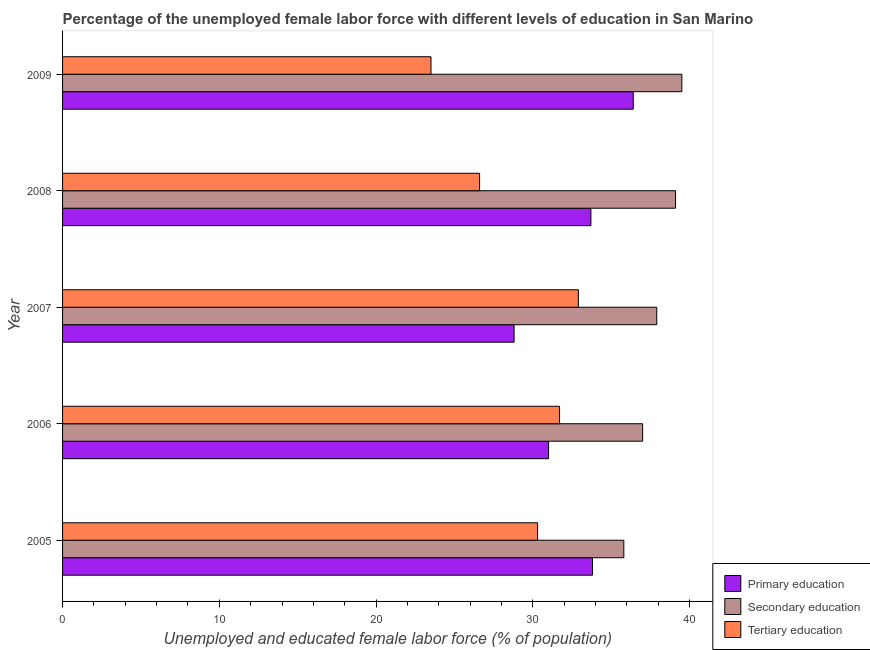How many different coloured bars are there?
Ensure brevity in your answer.  3. How many groups of bars are there?
Offer a very short reply. 5. Are the number of bars on each tick of the Y-axis equal?
Your response must be concise. Yes. How many bars are there on the 5th tick from the top?
Your response must be concise. 3. How many bars are there on the 2nd tick from the bottom?
Keep it short and to the point. 3. What is the label of the 5th group of bars from the top?
Your answer should be very brief. 2005. In how many cases, is the number of bars for a given year not equal to the number of legend labels?
Your answer should be very brief. 0. What is the percentage of female labor force who received secondary education in 2008?
Offer a very short reply. 39.1. Across all years, what is the maximum percentage of female labor force who received primary education?
Your answer should be very brief. 36.4. Across all years, what is the minimum percentage of female labor force who received primary education?
Make the answer very short. 28.8. In which year was the percentage of female labor force who received primary education minimum?
Your answer should be compact. 2007. What is the total percentage of female labor force who received secondary education in the graph?
Your response must be concise. 189.3. What is the difference between the percentage of female labor force who received tertiary education in 2008 and the percentage of female labor force who received secondary education in 2005?
Your response must be concise. -9.2. What is the ratio of the percentage of female labor force who received primary education in 2006 to that in 2009?
Make the answer very short. 0.85. What is the difference between the highest and the lowest percentage of female labor force who received tertiary education?
Your answer should be compact. 9.4. Is the sum of the percentage of female labor force who received primary education in 2006 and 2009 greater than the maximum percentage of female labor force who received tertiary education across all years?
Give a very brief answer. Yes. What does the 2nd bar from the top in 2007 represents?
Give a very brief answer. Secondary education. What does the 2nd bar from the bottom in 2005 represents?
Your answer should be very brief. Secondary education. Is it the case that in every year, the sum of the percentage of female labor force who received primary education and percentage of female labor force who received secondary education is greater than the percentage of female labor force who received tertiary education?
Your answer should be compact. Yes. How many bars are there?
Make the answer very short. 15. Does the graph contain grids?
Your response must be concise. No. Where does the legend appear in the graph?
Provide a succinct answer. Bottom right. What is the title of the graph?
Keep it short and to the point. Percentage of the unemployed female labor force with different levels of education in San Marino. Does "Travel services" appear as one of the legend labels in the graph?
Offer a terse response. No. What is the label or title of the X-axis?
Offer a very short reply. Unemployed and educated female labor force (% of population). What is the Unemployed and educated female labor force (% of population) of Primary education in 2005?
Offer a very short reply. 33.8. What is the Unemployed and educated female labor force (% of population) of Secondary education in 2005?
Ensure brevity in your answer.  35.8. What is the Unemployed and educated female labor force (% of population) of Tertiary education in 2005?
Your response must be concise. 30.3. What is the Unemployed and educated female labor force (% of population) of Primary education in 2006?
Ensure brevity in your answer.  31. What is the Unemployed and educated female labor force (% of population) in Tertiary education in 2006?
Offer a terse response. 31.7. What is the Unemployed and educated female labor force (% of population) in Primary education in 2007?
Your answer should be very brief. 28.8. What is the Unemployed and educated female labor force (% of population) of Secondary education in 2007?
Give a very brief answer. 37.9. What is the Unemployed and educated female labor force (% of population) of Tertiary education in 2007?
Your response must be concise. 32.9. What is the Unemployed and educated female labor force (% of population) of Primary education in 2008?
Make the answer very short. 33.7. What is the Unemployed and educated female labor force (% of population) of Secondary education in 2008?
Your answer should be very brief. 39.1. What is the Unemployed and educated female labor force (% of population) in Tertiary education in 2008?
Make the answer very short. 26.6. What is the Unemployed and educated female labor force (% of population) of Primary education in 2009?
Make the answer very short. 36.4. What is the Unemployed and educated female labor force (% of population) of Secondary education in 2009?
Offer a very short reply. 39.5. What is the Unemployed and educated female labor force (% of population) in Tertiary education in 2009?
Offer a terse response. 23.5. Across all years, what is the maximum Unemployed and educated female labor force (% of population) in Primary education?
Provide a succinct answer. 36.4. Across all years, what is the maximum Unemployed and educated female labor force (% of population) of Secondary education?
Give a very brief answer. 39.5. Across all years, what is the maximum Unemployed and educated female labor force (% of population) in Tertiary education?
Give a very brief answer. 32.9. Across all years, what is the minimum Unemployed and educated female labor force (% of population) in Primary education?
Your answer should be compact. 28.8. Across all years, what is the minimum Unemployed and educated female labor force (% of population) of Secondary education?
Offer a terse response. 35.8. Across all years, what is the minimum Unemployed and educated female labor force (% of population) of Tertiary education?
Keep it short and to the point. 23.5. What is the total Unemployed and educated female labor force (% of population) in Primary education in the graph?
Your answer should be very brief. 163.7. What is the total Unemployed and educated female labor force (% of population) in Secondary education in the graph?
Keep it short and to the point. 189.3. What is the total Unemployed and educated female labor force (% of population) of Tertiary education in the graph?
Give a very brief answer. 145. What is the difference between the Unemployed and educated female labor force (% of population) in Secondary education in 2005 and that in 2006?
Give a very brief answer. -1.2. What is the difference between the Unemployed and educated female labor force (% of population) in Tertiary education in 2005 and that in 2006?
Provide a succinct answer. -1.4. What is the difference between the Unemployed and educated female labor force (% of population) in Primary education in 2005 and that in 2008?
Your answer should be compact. 0.1. What is the difference between the Unemployed and educated female labor force (% of population) in Primary education in 2005 and that in 2009?
Give a very brief answer. -2.6. What is the difference between the Unemployed and educated female labor force (% of population) of Tertiary education in 2005 and that in 2009?
Offer a terse response. 6.8. What is the difference between the Unemployed and educated female labor force (% of population) of Tertiary education in 2006 and that in 2008?
Ensure brevity in your answer.  5.1. What is the difference between the Unemployed and educated female labor force (% of population) of Primary education in 2006 and that in 2009?
Provide a short and direct response. -5.4. What is the difference between the Unemployed and educated female labor force (% of population) in Secondary education in 2006 and that in 2009?
Keep it short and to the point. -2.5. What is the difference between the Unemployed and educated female labor force (% of population) of Primary education in 2007 and that in 2008?
Make the answer very short. -4.9. What is the difference between the Unemployed and educated female labor force (% of population) of Tertiary education in 2007 and that in 2008?
Give a very brief answer. 6.3. What is the difference between the Unemployed and educated female labor force (% of population) in Primary education in 2007 and that in 2009?
Make the answer very short. -7.6. What is the difference between the Unemployed and educated female labor force (% of population) of Secondary education in 2007 and that in 2009?
Ensure brevity in your answer.  -1.6. What is the difference between the Unemployed and educated female labor force (% of population) of Primary education in 2008 and that in 2009?
Offer a very short reply. -2.7. What is the difference between the Unemployed and educated female labor force (% of population) in Secondary education in 2008 and that in 2009?
Offer a very short reply. -0.4. What is the difference between the Unemployed and educated female labor force (% of population) of Primary education in 2005 and the Unemployed and educated female labor force (% of population) of Secondary education in 2006?
Offer a very short reply. -3.2. What is the difference between the Unemployed and educated female labor force (% of population) in Primary education in 2005 and the Unemployed and educated female labor force (% of population) in Tertiary education in 2008?
Give a very brief answer. 7.2. What is the difference between the Unemployed and educated female labor force (% of population) of Secondary education in 2005 and the Unemployed and educated female labor force (% of population) of Tertiary education in 2008?
Your response must be concise. 9.2. What is the difference between the Unemployed and educated female labor force (% of population) in Primary education in 2005 and the Unemployed and educated female labor force (% of population) in Secondary education in 2009?
Ensure brevity in your answer.  -5.7. What is the difference between the Unemployed and educated female labor force (% of population) of Primary education in 2005 and the Unemployed and educated female labor force (% of population) of Tertiary education in 2009?
Provide a short and direct response. 10.3. What is the difference between the Unemployed and educated female labor force (% of population) of Secondary education in 2005 and the Unemployed and educated female labor force (% of population) of Tertiary education in 2009?
Provide a short and direct response. 12.3. What is the difference between the Unemployed and educated female labor force (% of population) of Primary education in 2006 and the Unemployed and educated female labor force (% of population) of Secondary education in 2007?
Provide a short and direct response. -6.9. What is the difference between the Unemployed and educated female labor force (% of population) of Primary education in 2006 and the Unemployed and educated female labor force (% of population) of Tertiary education in 2007?
Provide a succinct answer. -1.9. What is the difference between the Unemployed and educated female labor force (% of population) in Secondary education in 2006 and the Unemployed and educated female labor force (% of population) in Tertiary education in 2008?
Your response must be concise. 10.4. What is the difference between the Unemployed and educated female labor force (% of population) of Primary education in 2006 and the Unemployed and educated female labor force (% of population) of Secondary education in 2009?
Keep it short and to the point. -8.5. What is the difference between the Unemployed and educated female labor force (% of population) in Primary education in 2006 and the Unemployed and educated female labor force (% of population) in Tertiary education in 2009?
Your response must be concise. 7.5. What is the difference between the Unemployed and educated female labor force (% of population) of Secondary education in 2006 and the Unemployed and educated female labor force (% of population) of Tertiary education in 2009?
Offer a very short reply. 13.5. What is the difference between the Unemployed and educated female labor force (% of population) of Primary education in 2007 and the Unemployed and educated female labor force (% of population) of Secondary education in 2008?
Make the answer very short. -10.3. What is the difference between the Unemployed and educated female labor force (% of population) of Secondary education in 2007 and the Unemployed and educated female labor force (% of population) of Tertiary education in 2008?
Give a very brief answer. 11.3. What is the difference between the Unemployed and educated female labor force (% of population) of Primary education in 2007 and the Unemployed and educated female labor force (% of population) of Secondary education in 2009?
Offer a very short reply. -10.7. What is the average Unemployed and educated female labor force (% of population) of Primary education per year?
Offer a terse response. 32.74. What is the average Unemployed and educated female labor force (% of population) in Secondary education per year?
Your answer should be compact. 37.86. What is the average Unemployed and educated female labor force (% of population) of Tertiary education per year?
Your answer should be compact. 29. In the year 2006, what is the difference between the Unemployed and educated female labor force (% of population) in Primary education and Unemployed and educated female labor force (% of population) in Tertiary education?
Offer a very short reply. -0.7. In the year 2006, what is the difference between the Unemployed and educated female labor force (% of population) of Secondary education and Unemployed and educated female labor force (% of population) of Tertiary education?
Give a very brief answer. 5.3. In the year 2007, what is the difference between the Unemployed and educated female labor force (% of population) in Primary education and Unemployed and educated female labor force (% of population) in Secondary education?
Make the answer very short. -9.1. In the year 2007, what is the difference between the Unemployed and educated female labor force (% of population) of Primary education and Unemployed and educated female labor force (% of population) of Tertiary education?
Your answer should be very brief. -4.1. In the year 2008, what is the difference between the Unemployed and educated female labor force (% of population) of Primary education and Unemployed and educated female labor force (% of population) of Tertiary education?
Your answer should be compact. 7.1. In the year 2008, what is the difference between the Unemployed and educated female labor force (% of population) of Secondary education and Unemployed and educated female labor force (% of population) of Tertiary education?
Ensure brevity in your answer.  12.5. In the year 2009, what is the difference between the Unemployed and educated female labor force (% of population) in Primary education and Unemployed and educated female labor force (% of population) in Secondary education?
Provide a short and direct response. -3.1. In the year 2009, what is the difference between the Unemployed and educated female labor force (% of population) of Primary education and Unemployed and educated female labor force (% of population) of Tertiary education?
Provide a short and direct response. 12.9. What is the ratio of the Unemployed and educated female labor force (% of population) in Primary education in 2005 to that in 2006?
Keep it short and to the point. 1.09. What is the ratio of the Unemployed and educated female labor force (% of population) of Secondary education in 2005 to that in 2006?
Your response must be concise. 0.97. What is the ratio of the Unemployed and educated female labor force (% of population) of Tertiary education in 2005 to that in 2006?
Your response must be concise. 0.96. What is the ratio of the Unemployed and educated female labor force (% of population) in Primary education in 2005 to that in 2007?
Make the answer very short. 1.17. What is the ratio of the Unemployed and educated female labor force (% of population) of Secondary education in 2005 to that in 2007?
Offer a very short reply. 0.94. What is the ratio of the Unemployed and educated female labor force (% of population) in Tertiary education in 2005 to that in 2007?
Give a very brief answer. 0.92. What is the ratio of the Unemployed and educated female labor force (% of population) in Primary education in 2005 to that in 2008?
Ensure brevity in your answer.  1. What is the ratio of the Unemployed and educated female labor force (% of population) in Secondary education in 2005 to that in 2008?
Your answer should be very brief. 0.92. What is the ratio of the Unemployed and educated female labor force (% of population) of Tertiary education in 2005 to that in 2008?
Your response must be concise. 1.14. What is the ratio of the Unemployed and educated female labor force (% of population) of Secondary education in 2005 to that in 2009?
Ensure brevity in your answer.  0.91. What is the ratio of the Unemployed and educated female labor force (% of population) of Tertiary education in 2005 to that in 2009?
Offer a terse response. 1.29. What is the ratio of the Unemployed and educated female labor force (% of population) in Primary education in 2006 to that in 2007?
Keep it short and to the point. 1.08. What is the ratio of the Unemployed and educated female labor force (% of population) of Secondary education in 2006 to that in 2007?
Provide a succinct answer. 0.98. What is the ratio of the Unemployed and educated female labor force (% of population) in Tertiary education in 2006 to that in 2007?
Give a very brief answer. 0.96. What is the ratio of the Unemployed and educated female labor force (% of population) of Primary education in 2006 to that in 2008?
Your response must be concise. 0.92. What is the ratio of the Unemployed and educated female labor force (% of population) in Secondary education in 2006 to that in 2008?
Offer a terse response. 0.95. What is the ratio of the Unemployed and educated female labor force (% of population) of Tertiary education in 2006 to that in 2008?
Offer a very short reply. 1.19. What is the ratio of the Unemployed and educated female labor force (% of population) in Primary education in 2006 to that in 2009?
Your answer should be compact. 0.85. What is the ratio of the Unemployed and educated female labor force (% of population) of Secondary education in 2006 to that in 2009?
Offer a terse response. 0.94. What is the ratio of the Unemployed and educated female labor force (% of population) in Tertiary education in 2006 to that in 2009?
Provide a succinct answer. 1.35. What is the ratio of the Unemployed and educated female labor force (% of population) of Primary education in 2007 to that in 2008?
Ensure brevity in your answer.  0.85. What is the ratio of the Unemployed and educated female labor force (% of population) of Secondary education in 2007 to that in 2008?
Your answer should be compact. 0.97. What is the ratio of the Unemployed and educated female labor force (% of population) of Tertiary education in 2007 to that in 2008?
Your answer should be very brief. 1.24. What is the ratio of the Unemployed and educated female labor force (% of population) in Primary education in 2007 to that in 2009?
Keep it short and to the point. 0.79. What is the ratio of the Unemployed and educated female labor force (% of population) in Secondary education in 2007 to that in 2009?
Your answer should be very brief. 0.96. What is the ratio of the Unemployed and educated female labor force (% of population) of Primary education in 2008 to that in 2009?
Your response must be concise. 0.93. What is the ratio of the Unemployed and educated female labor force (% of population) of Tertiary education in 2008 to that in 2009?
Provide a succinct answer. 1.13. What is the difference between the highest and the lowest Unemployed and educated female labor force (% of population) in Secondary education?
Offer a terse response. 3.7. What is the difference between the highest and the lowest Unemployed and educated female labor force (% of population) in Tertiary education?
Keep it short and to the point. 9.4. 